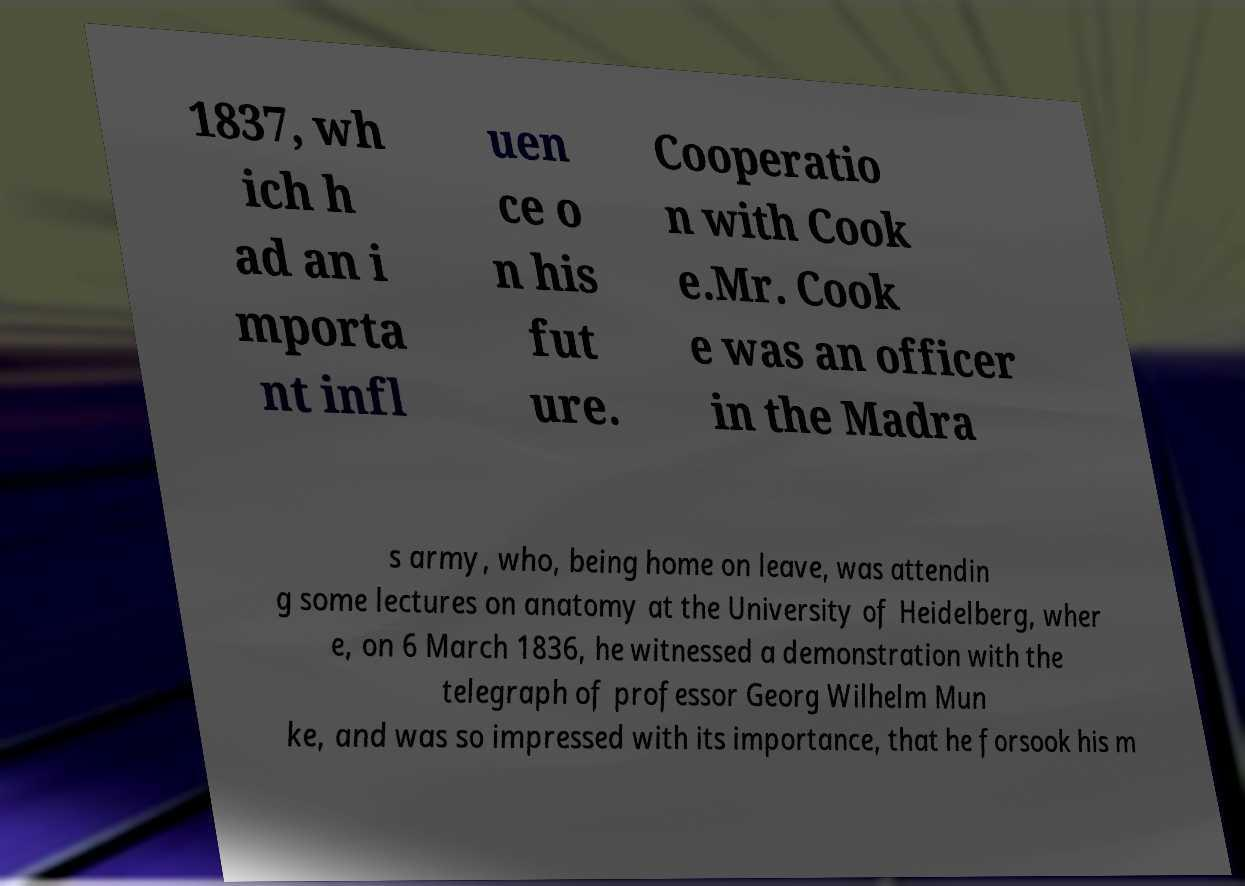For documentation purposes, I need the text within this image transcribed. Could you provide that? 1837, wh ich h ad an i mporta nt infl uen ce o n his fut ure. Cooperatio n with Cook e.Mr. Cook e was an officer in the Madra s army, who, being home on leave, was attendin g some lectures on anatomy at the University of Heidelberg, wher e, on 6 March 1836, he witnessed a demonstration with the telegraph of professor Georg Wilhelm Mun ke, and was so impressed with its importance, that he forsook his m 